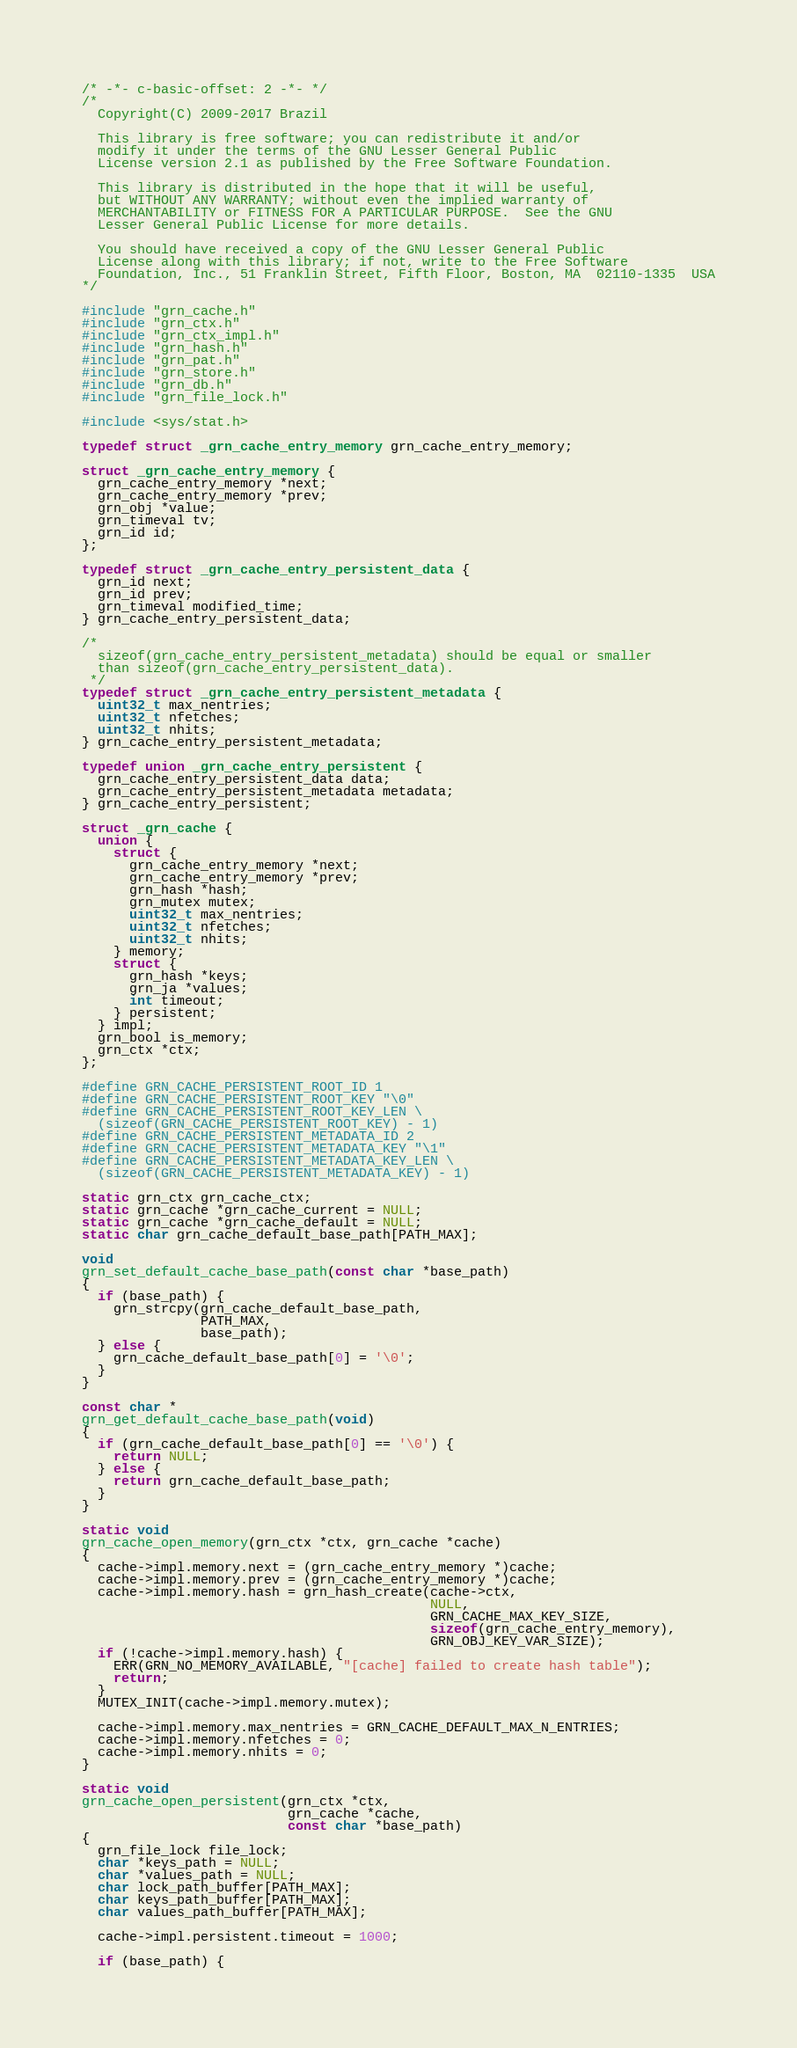Convert code to text. <code><loc_0><loc_0><loc_500><loc_500><_C_>/* -*- c-basic-offset: 2 -*- */
/*
  Copyright(C) 2009-2017 Brazil

  This library is free software; you can redistribute it and/or
  modify it under the terms of the GNU Lesser General Public
  License version 2.1 as published by the Free Software Foundation.

  This library is distributed in the hope that it will be useful,
  but WITHOUT ANY WARRANTY; without even the implied warranty of
  MERCHANTABILITY or FITNESS FOR A PARTICULAR PURPOSE.  See the GNU
  Lesser General Public License for more details.

  You should have received a copy of the GNU Lesser General Public
  License along with this library; if not, write to the Free Software
  Foundation, Inc., 51 Franklin Street, Fifth Floor, Boston, MA  02110-1335  USA
*/

#include "grn_cache.h"
#include "grn_ctx.h"
#include "grn_ctx_impl.h"
#include "grn_hash.h"
#include "grn_pat.h"
#include "grn_store.h"
#include "grn_db.h"
#include "grn_file_lock.h"

#include <sys/stat.h>

typedef struct _grn_cache_entry_memory grn_cache_entry_memory;

struct _grn_cache_entry_memory {
  grn_cache_entry_memory *next;
  grn_cache_entry_memory *prev;
  grn_obj *value;
  grn_timeval tv;
  grn_id id;
};

typedef struct _grn_cache_entry_persistent_data {
  grn_id next;
  grn_id prev;
  grn_timeval modified_time;
} grn_cache_entry_persistent_data;

/*
  sizeof(grn_cache_entry_persistent_metadata) should be equal or smaller
  than sizeof(grn_cache_entry_persistent_data).
 */
typedef struct _grn_cache_entry_persistent_metadata {
  uint32_t max_nentries;
  uint32_t nfetches;
  uint32_t nhits;
} grn_cache_entry_persistent_metadata;

typedef union _grn_cache_entry_persistent {
  grn_cache_entry_persistent_data data;
  grn_cache_entry_persistent_metadata metadata;
} grn_cache_entry_persistent;

struct _grn_cache {
  union {
    struct {
      grn_cache_entry_memory *next;
      grn_cache_entry_memory *prev;
      grn_hash *hash;
      grn_mutex mutex;
      uint32_t max_nentries;
      uint32_t nfetches;
      uint32_t nhits;
    } memory;
    struct {
      grn_hash *keys;
      grn_ja *values;
      int timeout;
    } persistent;
  } impl;
  grn_bool is_memory;
  grn_ctx *ctx;
};

#define GRN_CACHE_PERSISTENT_ROOT_ID 1
#define GRN_CACHE_PERSISTENT_ROOT_KEY "\0"
#define GRN_CACHE_PERSISTENT_ROOT_KEY_LEN \
  (sizeof(GRN_CACHE_PERSISTENT_ROOT_KEY) - 1)
#define GRN_CACHE_PERSISTENT_METADATA_ID 2
#define GRN_CACHE_PERSISTENT_METADATA_KEY "\1"
#define GRN_CACHE_PERSISTENT_METADATA_KEY_LEN \
  (sizeof(GRN_CACHE_PERSISTENT_METADATA_KEY) - 1)

static grn_ctx grn_cache_ctx;
static grn_cache *grn_cache_current = NULL;
static grn_cache *grn_cache_default = NULL;
static char grn_cache_default_base_path[PATH_MAX];

void
grn_set_default_cache_base_path(const char *base_path)
{
  if (base_path) {
    grn_strcpy(grn_cache_default_base_path,
               PATH_MAX,
               base_path);
  } else {
    grn_cache_default_base_path[0] = '\0';
  }
}

const char *
grn_get_default_cache_base_path(void)
{
  if (grn_cache_default_base_path[0] == '\0') {
    return NULL;
  } else {
    return grn_cache_default_base_path;
  }
}

static void
grn_cache_open_memory(grn_ctx *ctx, grn_cache *cache)
{
  cache->impl.memory.next = (grn_cache_entry_memory *)cache;
  cache->impl.memory.prev = (grn_cache_entry_memory *)cache;
  cache->impl.memory.hash = grn_hash_create(cache->ctx,
                                            NULL,
                                            GRN_CACHE_MAX_KEY_SIZE,
                                            sizeof(grn_cache_entry_memory),
                                            GRN_OBJ_KEY_VAR_SIZE);
  if (!cache->impl.memory.hash) {
    ERR(GRN_NO_MEMORY_AVAILABLE, "[cache] failed to create hash table");
    return;
  }
  MUTEX_INIT(cache->impl.memory.mutex);

  cache->impl.memory.max_nentries = GRN_CACHE_DEFAULT_MAX_N_ENTRIES;
  cache->impl.memory.nfetches = 0;
  cache->impl.memory.nhits = 0;
}

static void
grn_cache_open_persistent(grn_ctx *ctx,
                          grn_cache *cache,
                          const char *base_path)
{
  grn_file_lock file_lock;
  char *keys_path = NULL;
  char *values_path = NULL;
  char lock_path_buffer[PATH_MAX];
  char keys_path_buffer[PATH_MAX];
  char values_path_buffer[PATH_MAX];

  cache->impl.persistent.timeout = 1000;

  if (base_path) {</code> 